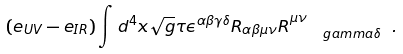Convert formula to latex. <formula><loc_0><loc_0><loc_500><loc_500>( e _ { U V } - e _ { I R } ) \int d ^ { 4 } x \sqrt { g } \tau { \epsilon } ^ { \alpha \beta \gamma \delta } { R } _ { \alpha \beta \mu \nu } { R } ^ { \mu \nu } _ { \quad g a m m a \delta } \ .</formula> 